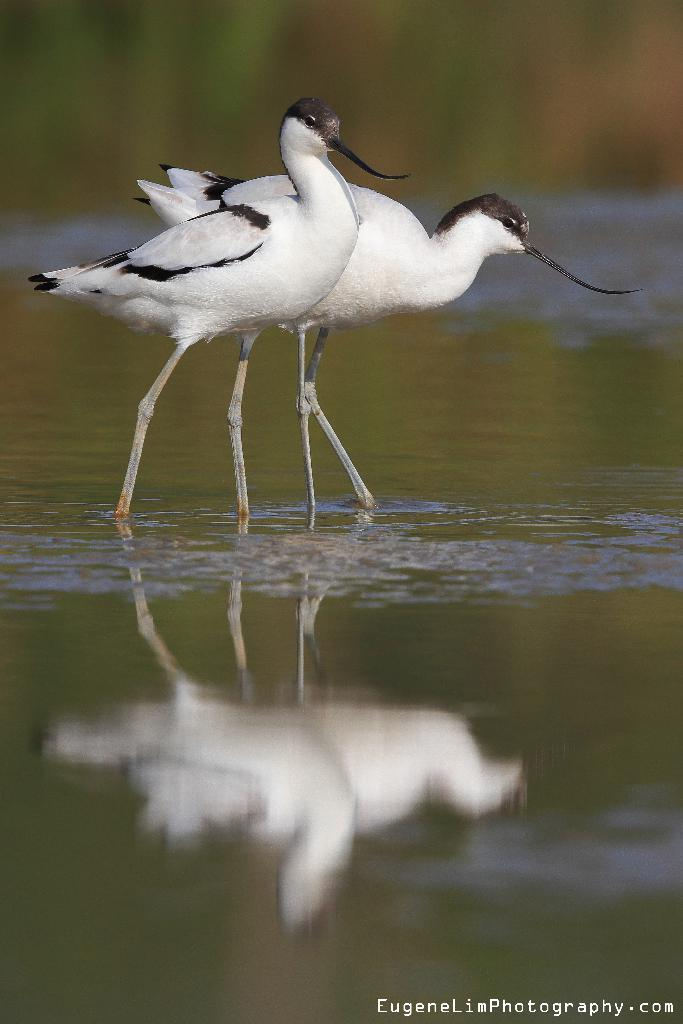What type of animals can be seen in the image? There are two white color birds in the image. Where are the birds located in the image? The birds are standing in the water. Can you describe the background of the image? The background of the image is blurred. Is there any additional information or marking on the image? Yes, there is a watermark on the bottom of the image. What type of fuel can be seen in the image? There is no fuel present in the image; it features two white color birds standing in the water. What type of floor is visible in the image? The image does not show a floor, as it features birds standing in the water. 